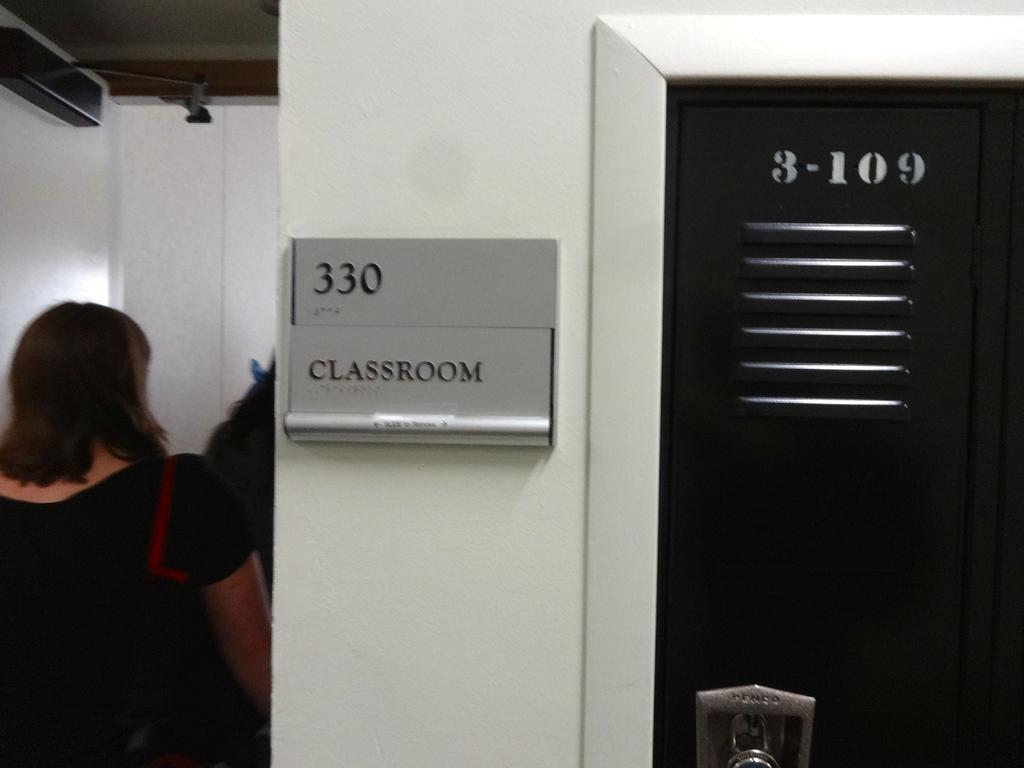How would you summarize this image in a sentence or two? This picture is clicked inside. On the right we can see a black color door. In the center there is a white color and we can see a board attached to the pillar and we can see the number and the text on the board. On the left we can see the two persons and a white color door and a wall. At the top there is a roof. 